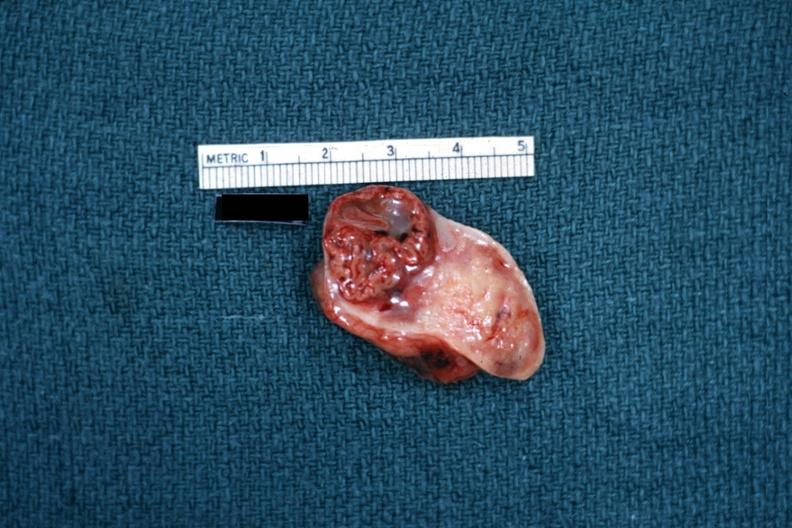s lymphoma present?
Answer the question using a single word or phrase. No 